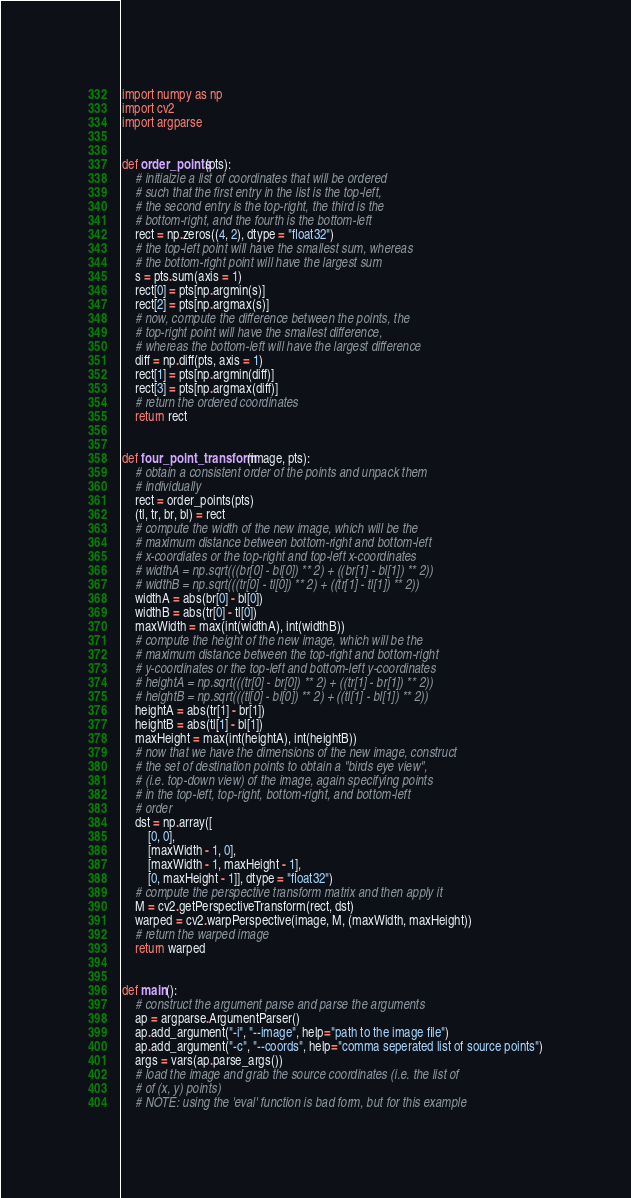Convert code to text. <code><loc_0><loc_0><loc_500><loc_500><_Python_>import numpy as np
import cv2
import argparse


def order_points(pts):
    # initialzie a list of coordinates that will be ordered
    # such that the first entry in the list is the top-left,
    # the second entry is the top-right, the third is the
    # bottom-right, and the fourth is the bottom-left
    rect = np.zeros((4, 2), dtype = "float32")
    # the top-left point will have the smallest sum, whereas
    # the bottom-right point will have the largest sum
    s = pts.sum(axis = 1)
    rect[0] = pts[np.argmin(s)]
    rect[2] = pts[np.argmax(s)]
    # now, compute the difference between the points, the
    # top-right point will have the smallest difference,
    # whereas the bottom-left will have the largest difference
    diff = np.diff(pts, axis = 1)
    rect[1] = pts[np.argmin(diff)]
    rect[3] = pts[np.argmax(diff)]
    # return the ordered coordinates
    return rect


def four_point_transform(image, pts):
    # obtain a consistent order of the points and unpack them
    # individually
    rect = order_points(pts)
    (tl, tr, br, bl) = rect
    # compute the width of the new image, which will be the
    # maximum distance between bottom-right and bottom-left
    # x-coordiates or the top-right and top-left x-coordinates
    # widthA = np.sqrt(((br[0] - bl[0]) ** 2) + ((br[1] - bl[1]) ** 2))
    # widthB = np.sqrt(((tr[0] - tl[0]) ** 2) + ((tr[1] - tl[1]) ** 2))
    widthA = abs(br[0] - bl[0])
    widthB = abs(tr[0] - tl[0])
    maxWidth = max(int(widthA), int(widthB))
    # compute the height of the new image, which will be the
    # maximum distance between the top-right and bottom-right
    # y-coordinates or the top-left and bottom-left y-coordinates
    # heightA = np.sqrt(((tr[0] - br[0]) ** 2) + ((tr[1] - br[1]) ** 2))
    # heightB = np.sqrt(((tl[0] - bl[0]) ** 2) + ((tl[1] - bl[1]) ** 2))
    heightA = abs(tr[1] - br[1])
    heightB = abs(tl[1] - bl[1])
    maxHeight = max(int(heightA), int(heightB))
    # now that we have the dimensions of the new image, construct
    # the set of destination points to obtain a "birds eye view",
    # (i.e. top-down view) of the image, again specifying points
    # in the top-left, top-right, bottom-right, and bottom-left
    # order
    dst = np.array([
        [0, 0],
        [maxWidth - 1, 0],
        [maxWidth - 1, maxHeight - 1],
        [0, maxHeight - 1]], dtype = "float32")
    # compute the perspective transform matrix and then apply it
    M = cv2.getPerspectiveTransform(rect, dst)
    warped = cv2.warpPerspective(image, M, (maxWidth, maxHeight))
    # return the warped image
    return warped


def main():
    # construct the argument parse and parse the arguments
    ap = argparse.ArgumentParser()
    ap.add_argument("-i", "--image", help="path to the image file")
    ap.add_argument("-c", "--coords", help="comma seperated list of source points")
    args = vars(ap.parse_args())
    # load the image and grab the source coordinates (i.e. the list of
    # of (x, y) points)
    # NOTE: using the 'eval' function is bad form, but for this example</code> 